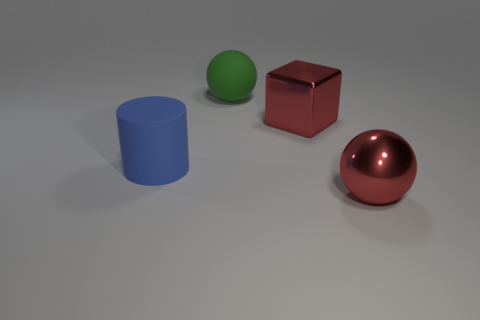How many big things are to the left of the red metallic thing that is in front of the big red block? 3 